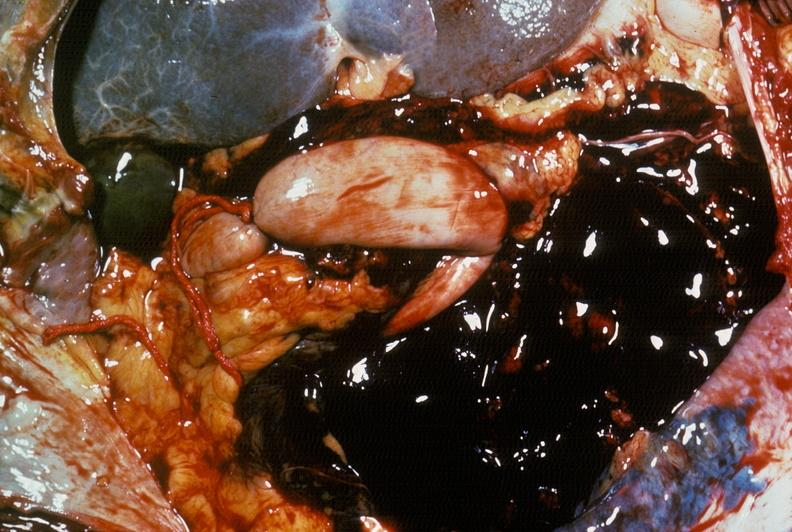does this image show hemorrhage secondary to ruptured aneurysm?
Answer the question using a single word or phrase. Yes 